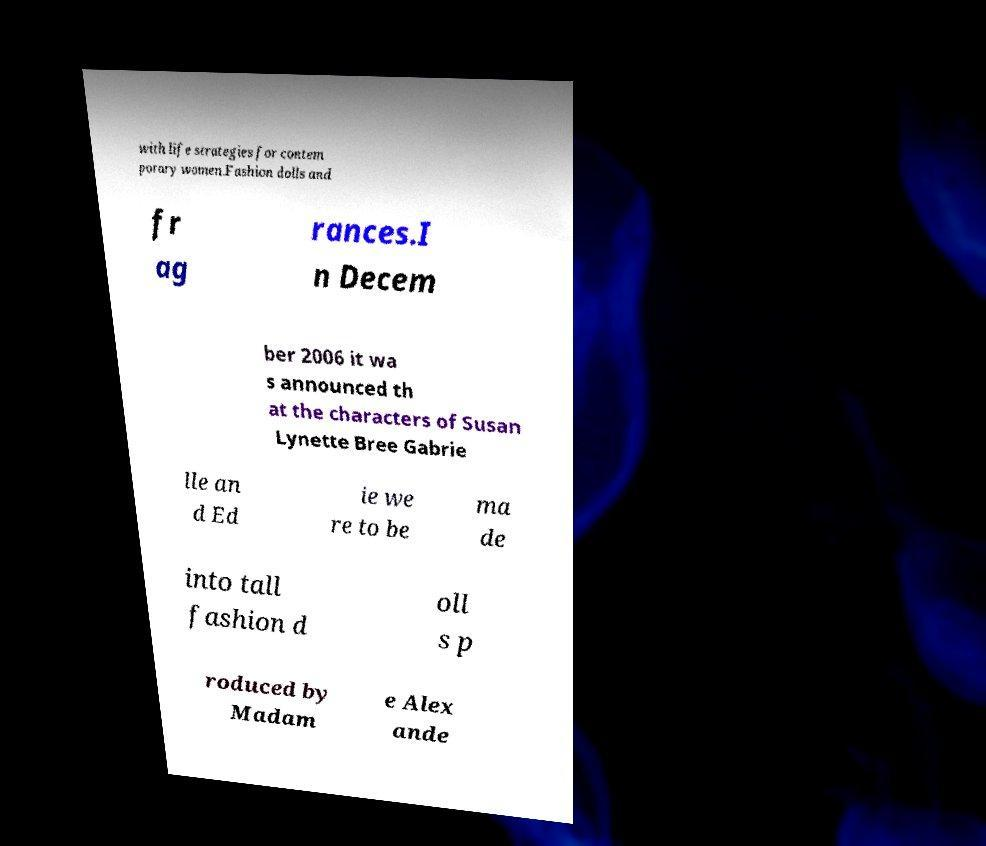I need the written content from this picture converted into text. Can you do that? with life strategies for contem porary women.Fashion dolls and fr ag rances.I n Decem ber 2006 it wa s announced th at the characters of Susan Lynette Bree Gabrie lle an d Ed ie we re to be ma de into tall fashion d oll s p roduced by Madam e Alex ande 